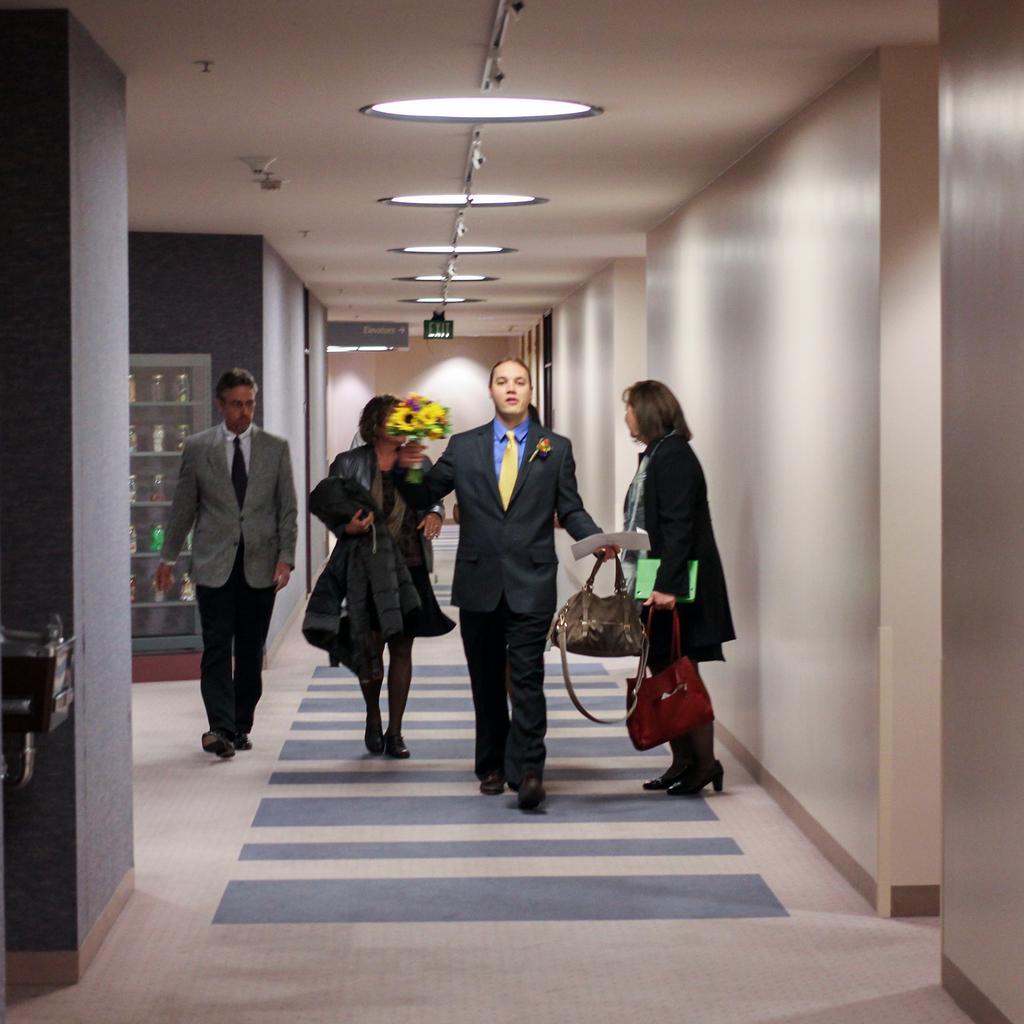How would you summarize this image in a sentence or two? In the picture I can see people are walking, few are holding bags, side there is a shelf filled with objects and some light to the roof. 